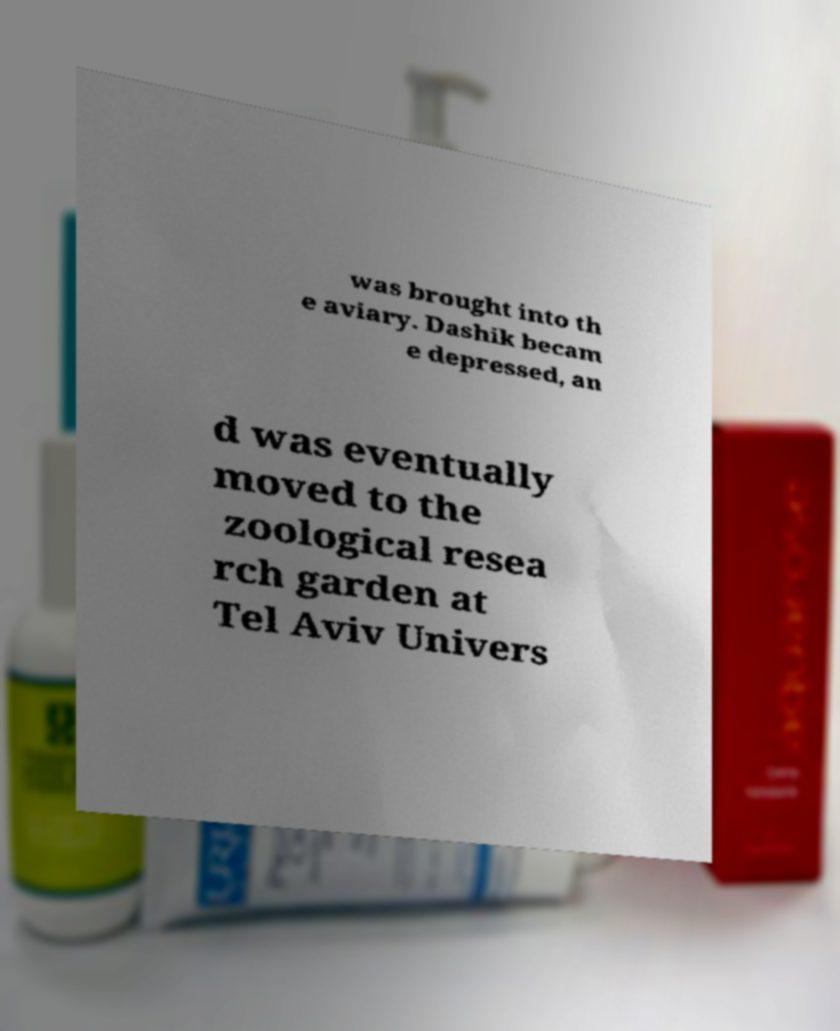Please identify and transcribe the text found in this image. was brought into th e aviary. Dashik becam e depressed, an d was eventually moved to the zoological resea rch garden at Tel Aviv Univers 